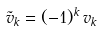Convert formula to latex. <formula><loc_0><loc_0><loc_500><loc_500>\tilde { v } _ { k } = ( - 1 ) ^ { k } \, v _ { k }</formula> 